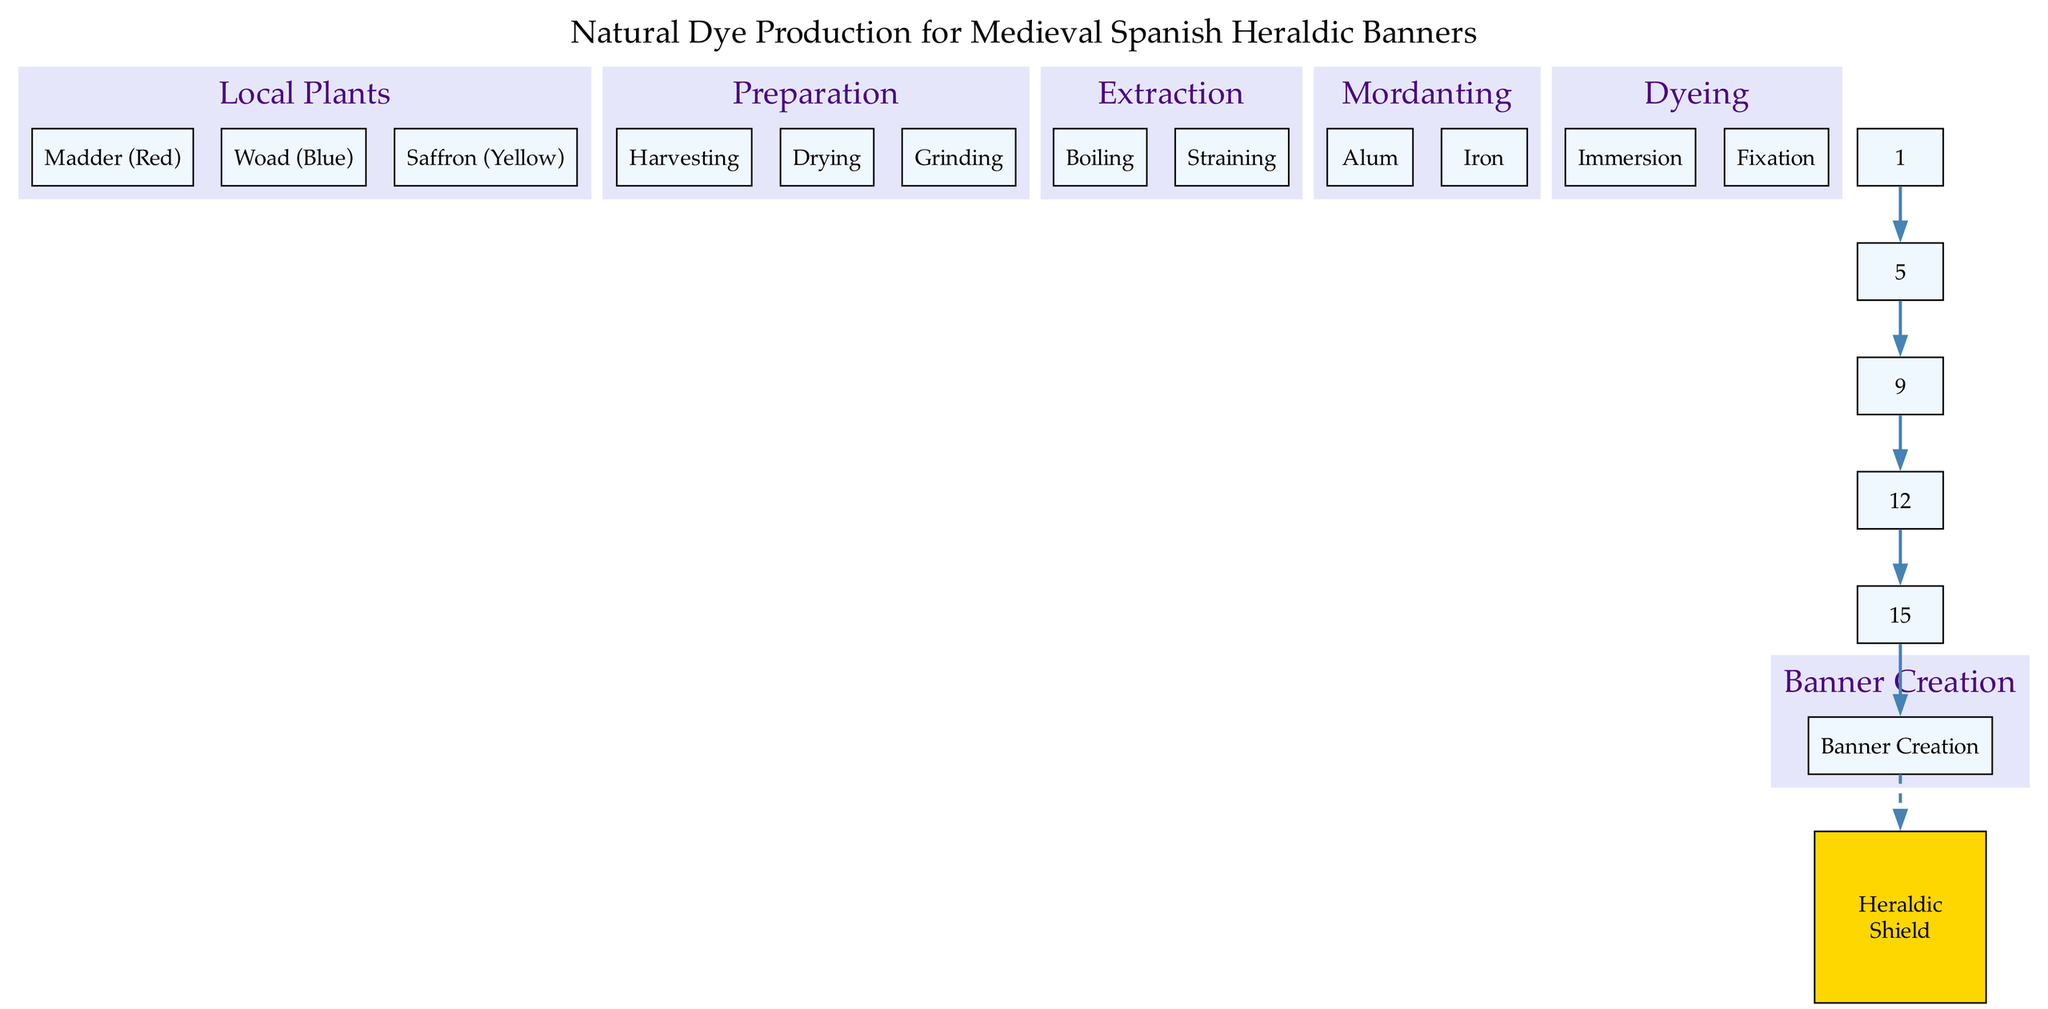What is the title of the diagram? The title of the diagram is explicitly provided at the top, describing the overall theme. It states the process being depicted, which is related to natural dye production used in heraldic banners.
Answer: Natural Dye Production for Medieval Spanish Heraldic Banners How many local plants are used for dye production? The diagram lists three local plants that are utilized in the dye production process. Each plant is clearly categorized under the "Local Plants" node.
Answer: 3 What is the first step in the preparation process? Looking at the "Preparation" node, the first child node is labeled "Harvesting." This indicates that harvesting is the initial step before proceeding to other stages in the preparation.
Answer: Harvesting Which color is associated with Madder? In the "Local Plants" section, Madder is specifically labeled with the color "Red." This association directly aligns the plant with its corresponding dye color.
Answer: Red What are the two steps involved in the extraction process? The extraction process comprises two child nodes labeled "Boiling" and "Straining." Both steps are necessary to extract the dye from the plant materials.
Answer: Boiling, Straining What is the final step before the creation of the banner? The diagram shows that before the "Banner Creation" node, the last process is "Dyeing." This indicates that dyeing is the preceding step necessary for preparing the banner.
Answer: Dyeing Which mordant is grouped with Alum? In the "Mordanting" section, under the same node as Alum, there is another child node labeled "Iron." This categorizes both mordants together within the dyeing process.
Answer: Iron How many edges are there connecting the main processes? By examining the diagram's edges, we can count a total of five edges connecting the main processes, representing the flow from one step to the next in the dye production.
Answer: 5 What type of shape is used for the heraldic element? The diagram specifies that the heraldic element is represented by a shield shape, which is commonly associated with heraldry and visual representation in banners.
Answer: Shield 